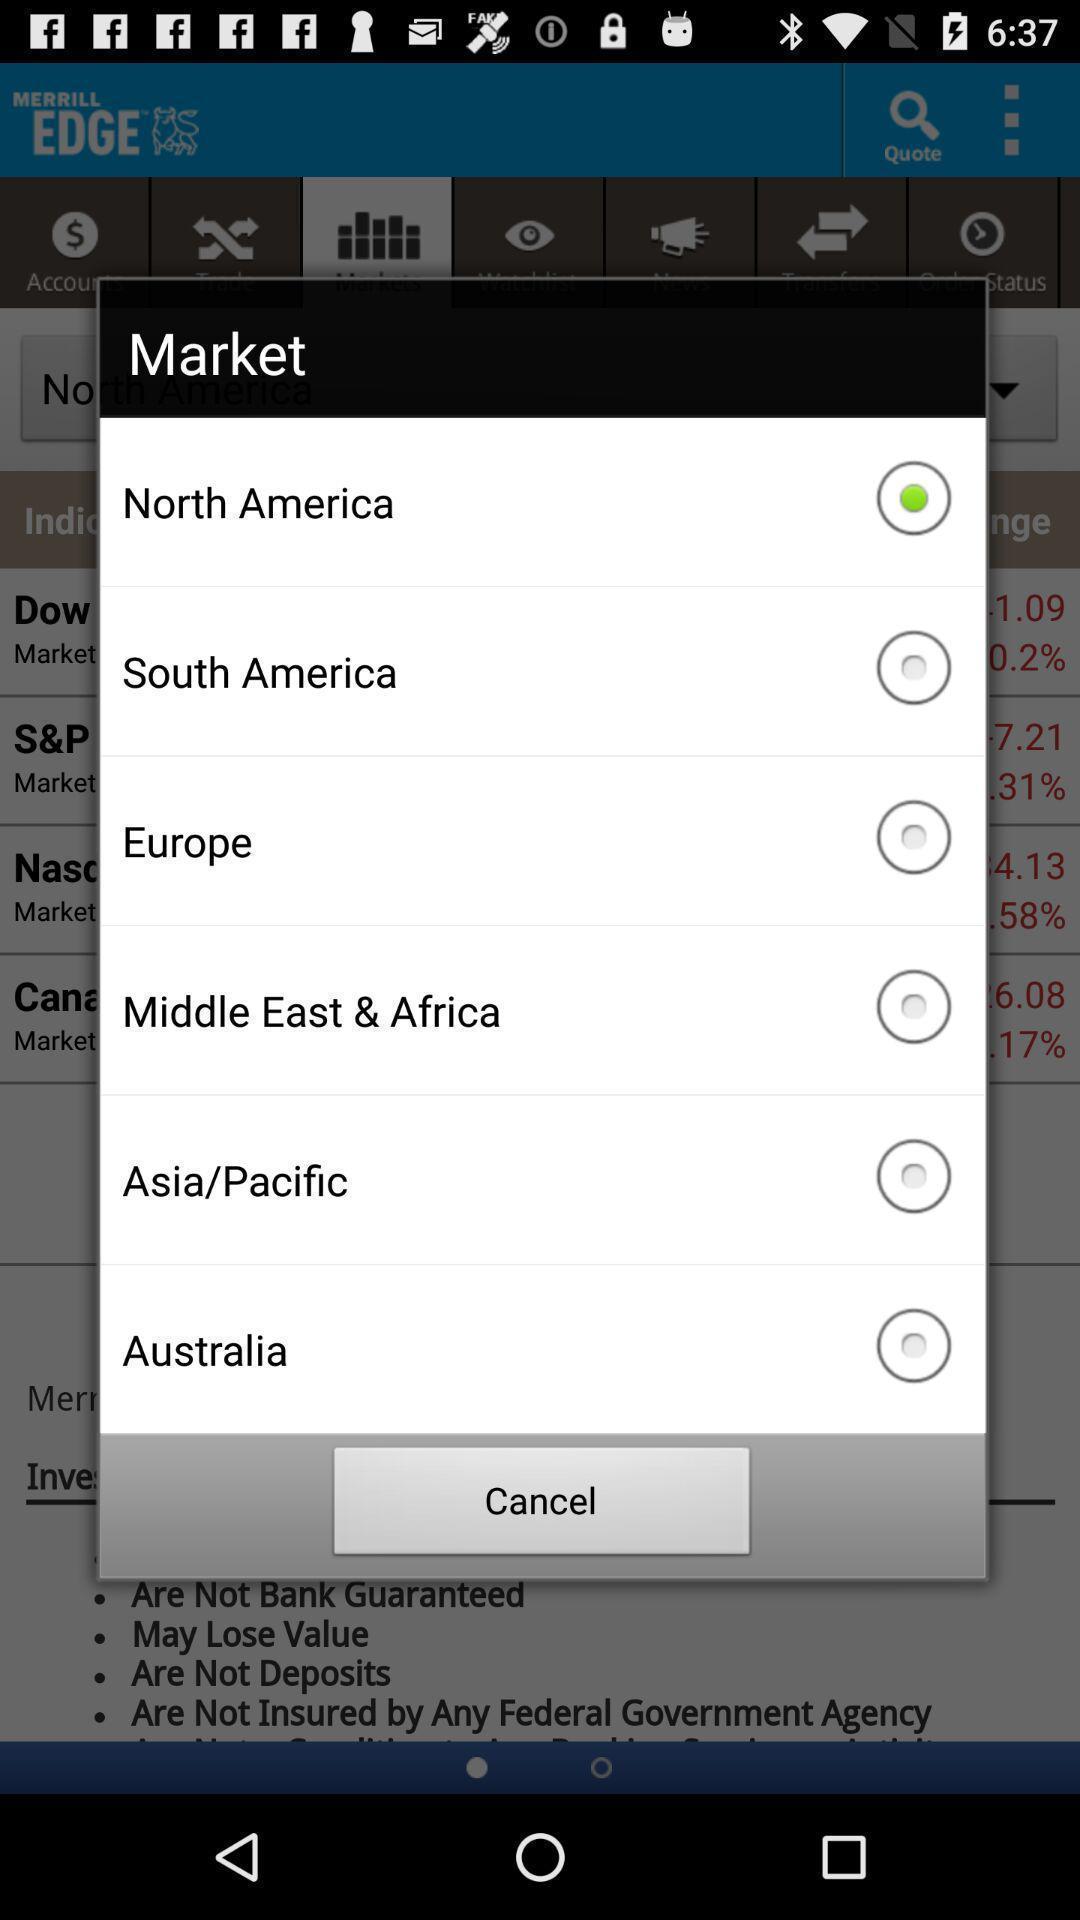Describe the visual elements of this screenshot. Popup for choosing a country in a business app. 